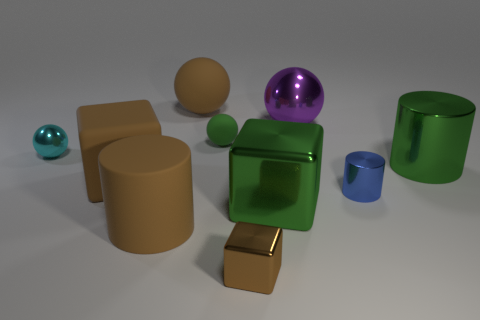There is a sphere in front of the tiny ball behind the small cyan thing; what is its color?
Ensure brevity in your answer.  Cyan. What number of things are in front of the large green cylinder and to the left of the large matte cylinder?
Your answer should be compact. 1. What number of brown matte things have the same shape as the brown metallic thing?
Offer a very short reply. 1. Do the small brown thing and the big purple object have the same material?
Offer a terse response. Yes. There is a big green thing that is in front of the big metal cylinder behind the large brown cylinder; what is its shape?
Your response must be concise. Cube. There is a small object on the left side of the large brown rubber sphere; how many big brown balls are left of it?
Make the answer very short. 0. There is a sphere that is both to the left of the small green rubber thing and right of the cyan thing; what material is it?
Offer a very short reply. Rubber. The blue object that is the same size as the green sphere is what shape?
Provide a succinct answer. Cylinder. There is a rubber sphere that is behind the sphere that is on the right side of the small ball that is behind the tiny cyan thing; what is its color?
Your answer should be very brief. Brown. How many objects are either big brown things that are left of the matte cylinder or blue shiny objects?
Keep it short and to the point. 2. 